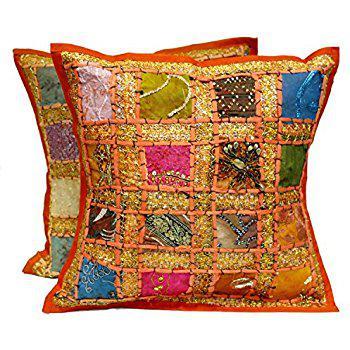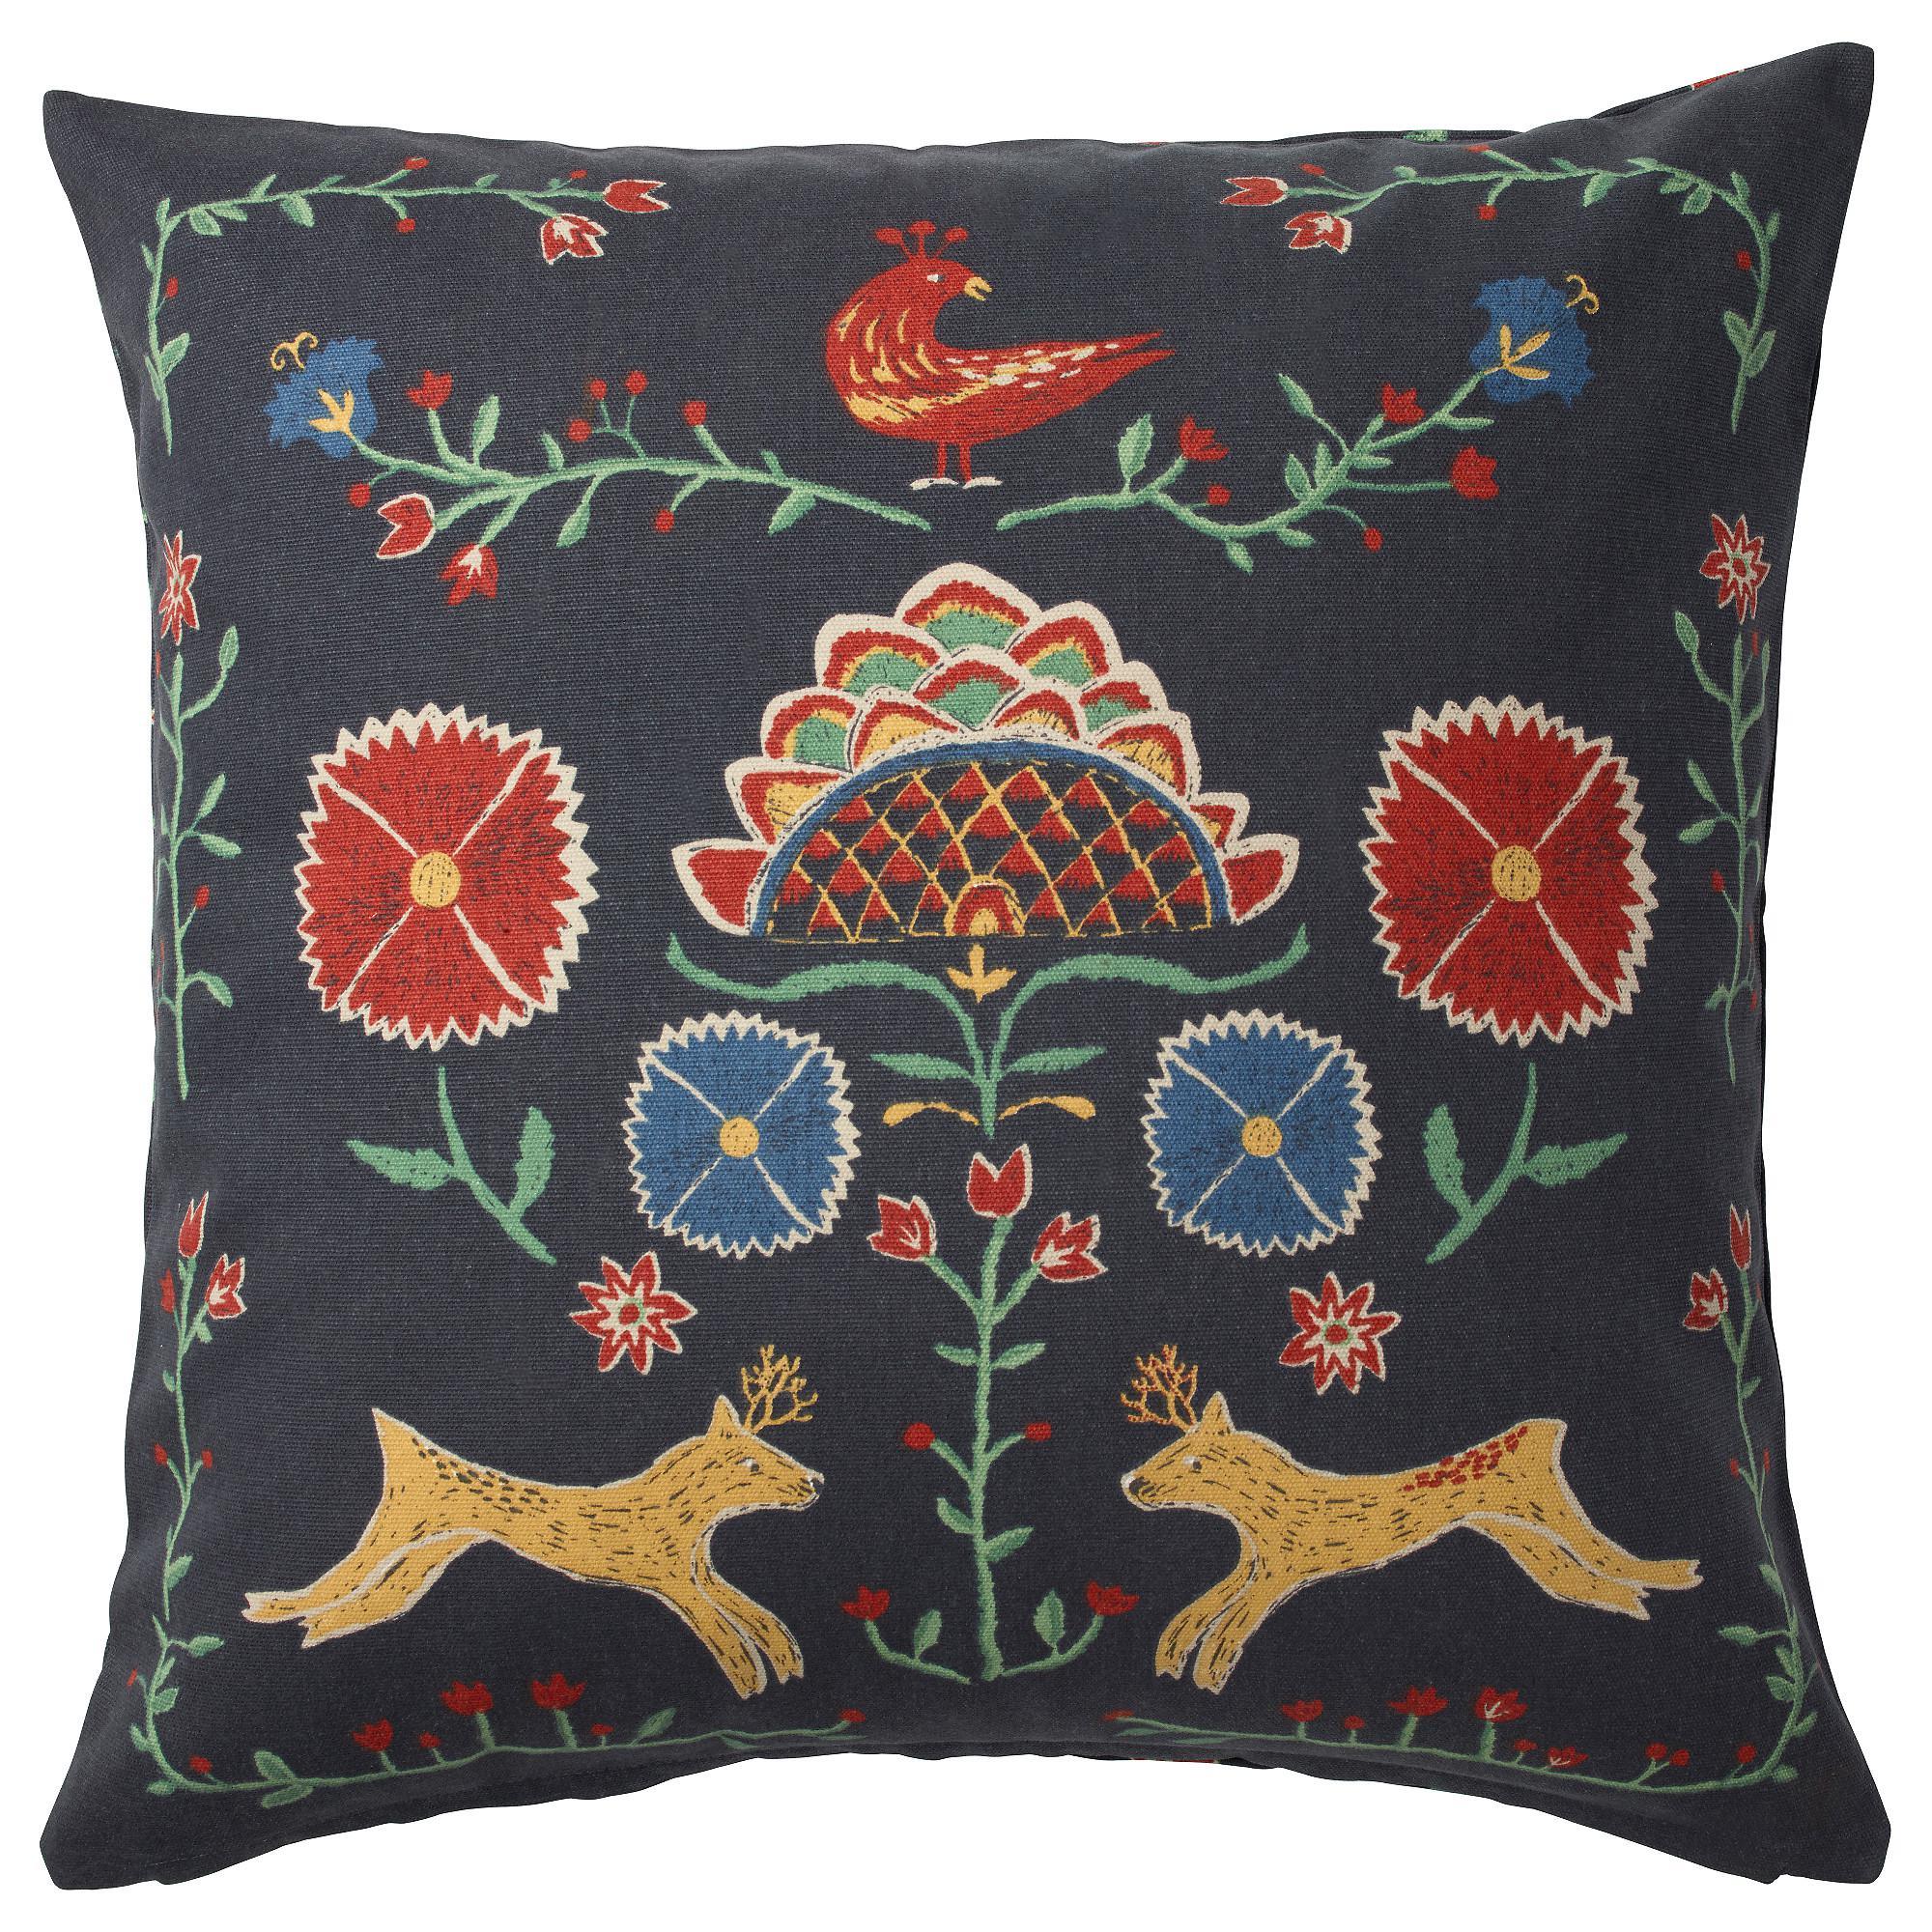The first image is the image on the left, the second image is the image on the right. For the images shown, is this caption "All of the pillows in one image feature multicolored birds on branches and have a pale neutral background color." true? Answer yes or no. No. The first image is the image on the left, the second image is the image on the right. For the images shown, is this caption "The left image has exactly five pillows." true? Answer yes or no. No. 